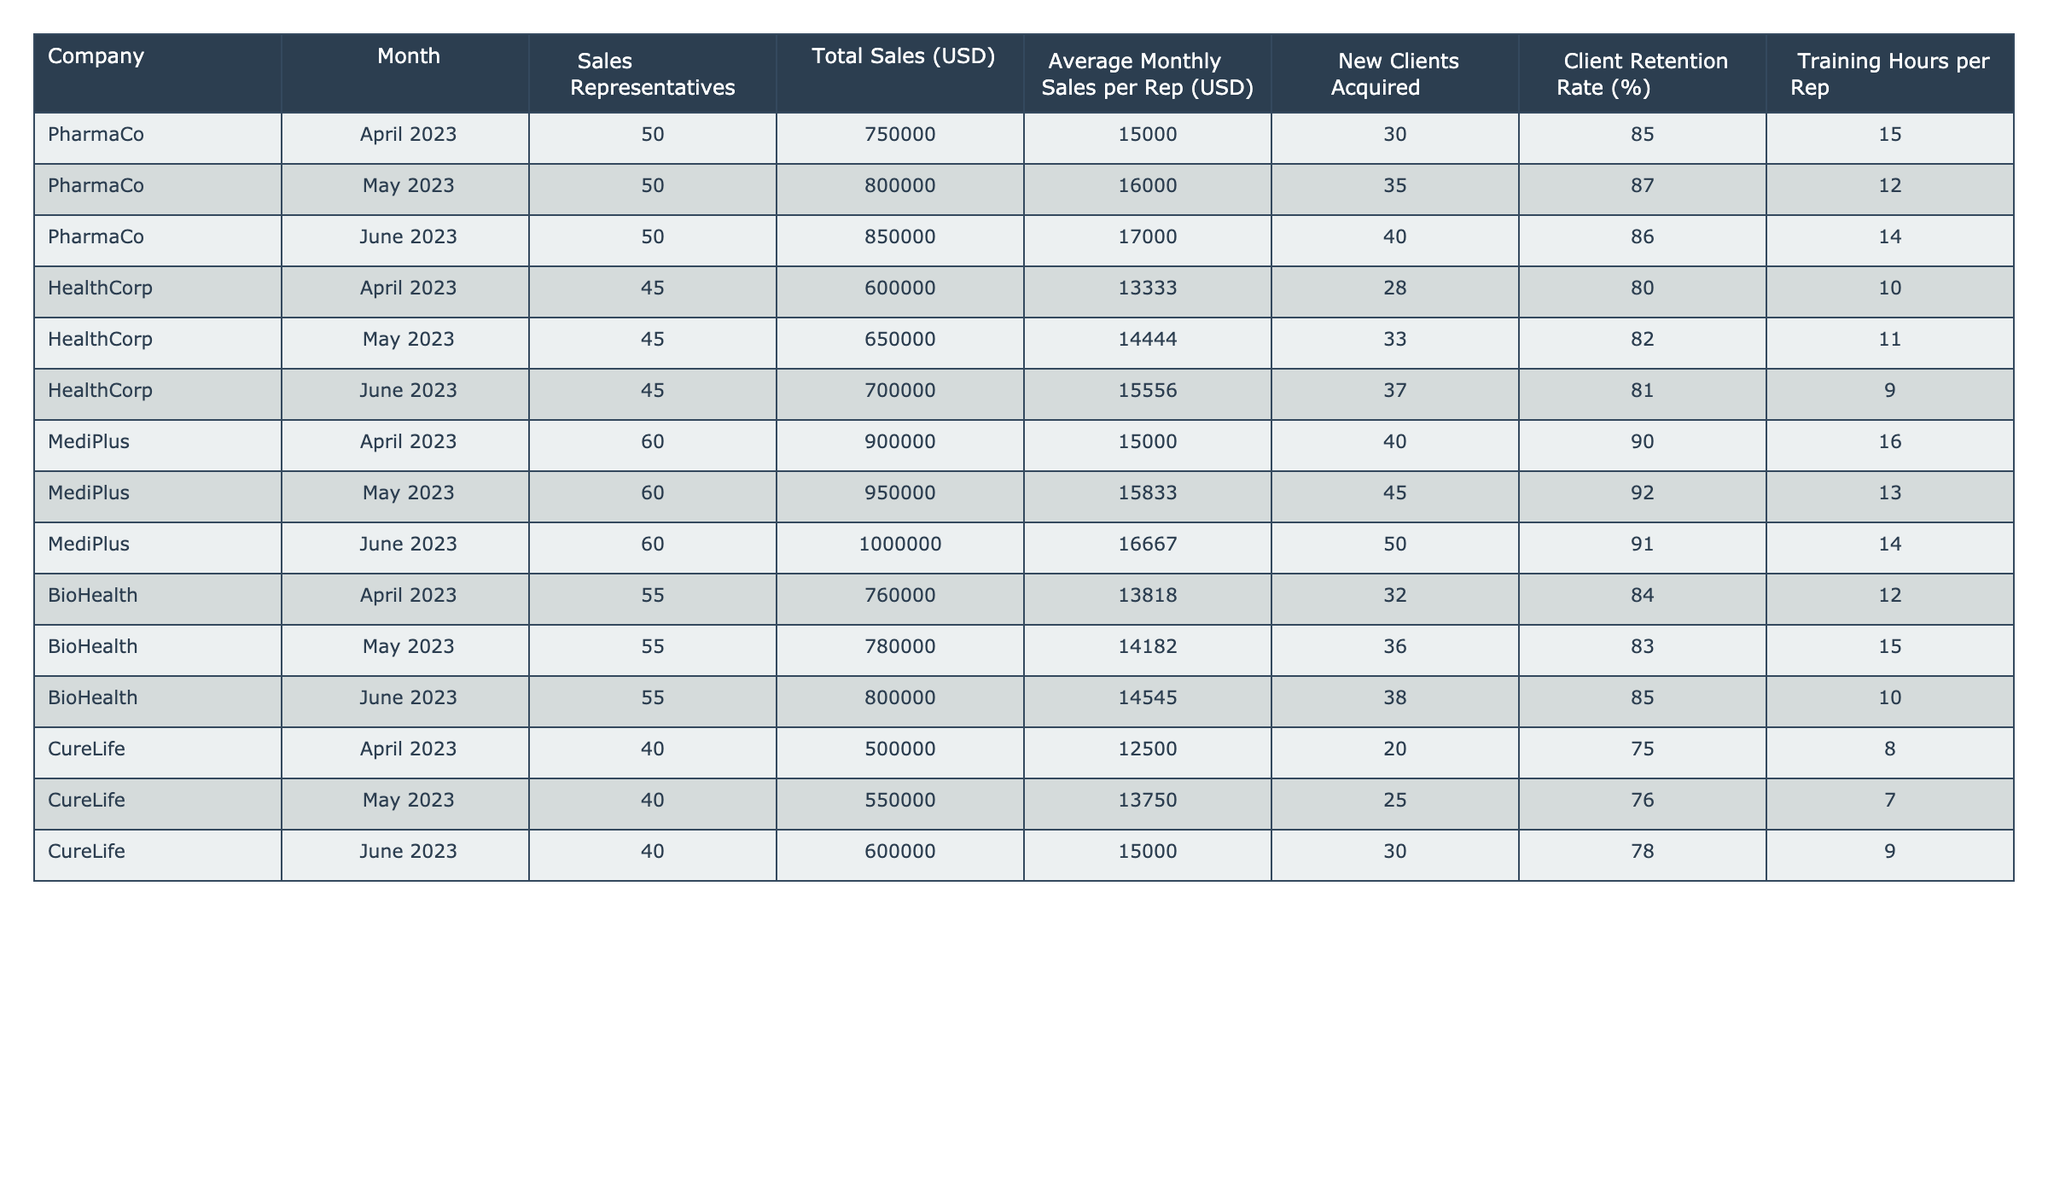What was the total sales for PharmaCo in June 2023? In June 2023, the total sales reported for PharmaCo are $850,000 as listed in the table.
Answer: 850000 Which company acquired the most new clients in May 2023? In May 2023, PharmaCo acquired 35 new clients, which is the highest number compared to other companies' new clients for that month.
Answer: PharmaCo What is the client retention rate for MediPlus in April 2023? The client retention rate for MediPlus in April 2023 is 90% as presented in the table.
Answer: 90 Calculate the average monthly sales per representative for HealthCorp over the three months. For HealthCorp, the sales figures per representative are: April (13333), May (14444), and June (15556). The average is (13333 + 14444 + 15556) / 3 = 14444.33.
Answer: 14444.33 Did BioHealth increase its total sales from April to May 2023? Yes, BioHealth's sales increased from $760,000 in April to $780,000 in May, indicating growth over that month.
Answer: Yes How many training hours did MediPlus invest per representative on average in the past three months? MediPlus's training hours per representative for the three months are April (16), May (13), and June (14). The average is (16 + 13 + 14) / 3 = 14.33.
Answer: 14.33 Which company had the lowest average monthly sales per rep in June 2023? In June 2023, CureLife had the lowest average monthly sales per representative at $15,000.
Answer: CureLife What was the increase in total sales for BioHealth from April to June 2023? BioHealth’s total sales increased from $760,000 in April to $800,000 in June. The increase is $800,000 - $760,000 = $40,000.
Answer: 40000 Did all companies have a client retention rate above 80% in May 2023? No, CureLife had a client retention rate of 76% in May 2023, which is below 80%.
Answer: No What was the total number of sales representatives across all companies in May 2023? Summing the sales representatives in May gives: PharmaCo (50) + HealthCorp (45) + MediPlus (60) + BioHealth (55) + CureLife (40) = 250 total sales representatives.
Answer: 250 